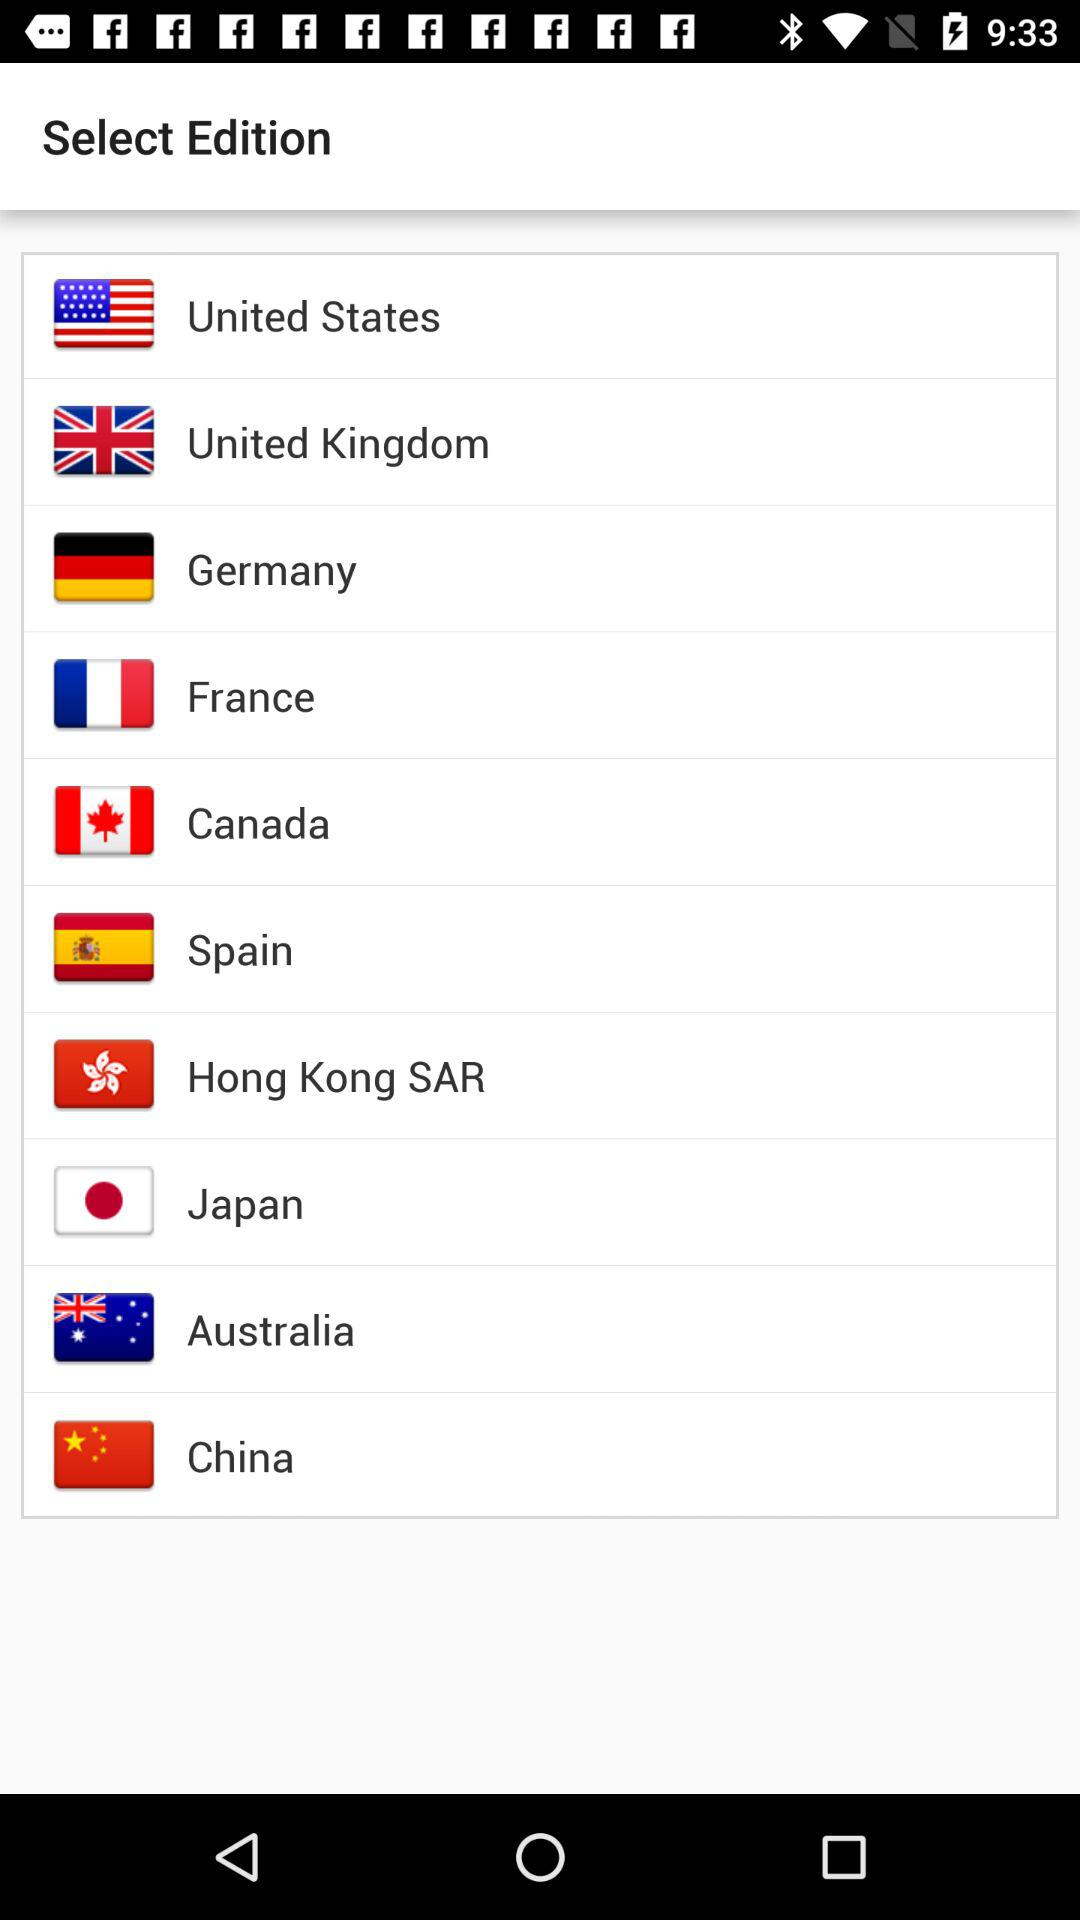How many countries are available for edition selection?
Answer the question using a single word or phrase. 10 